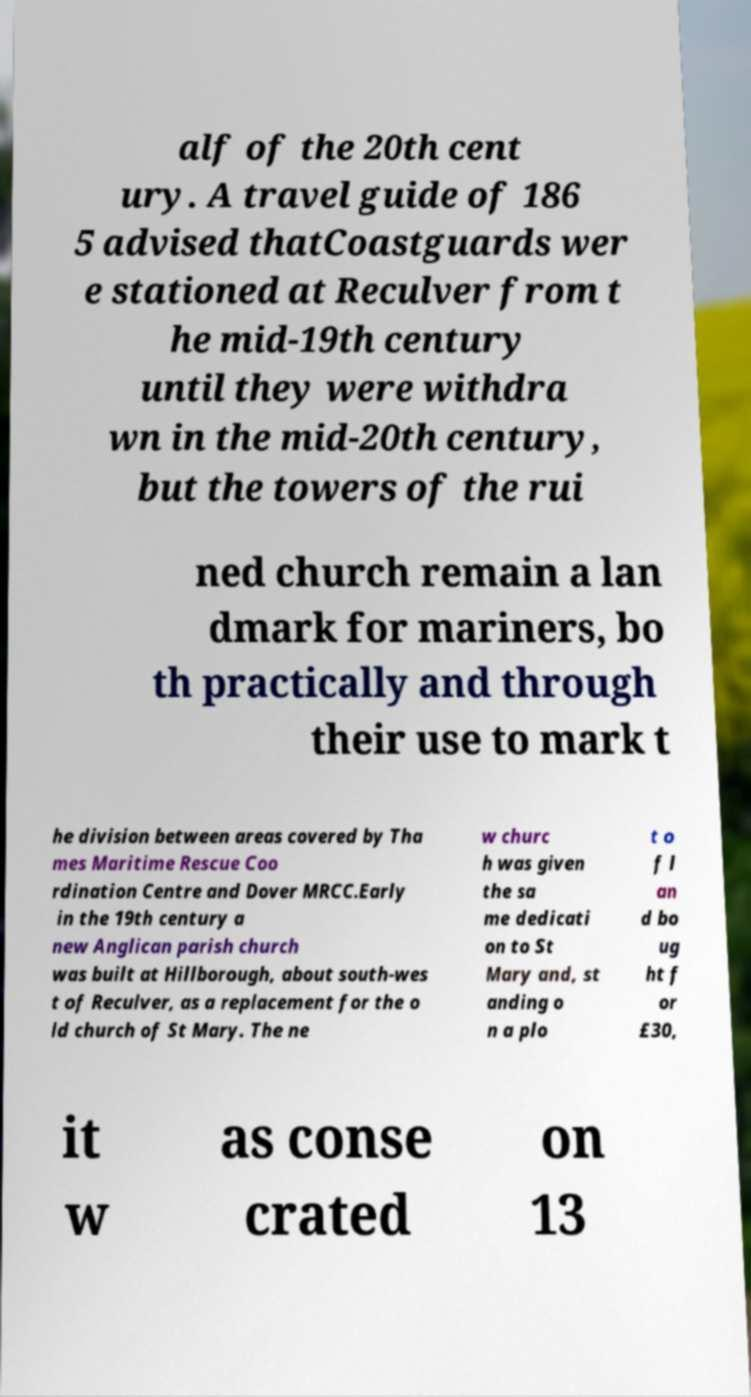Could you assist in decoding the text presented in this image and type it out clearly? alf of the 20th cent ury. A travel guide of 186 5 advised thatCoastguards wer e stationed at Reculver from t he mid-19th century until they were withdra wn in the mid-20th century, but the towers of the rui ned church remain a lan dmark for mariners, bo th practically and through their use to mark t he division between areas covered by Tha mes Maritime Rescue Coo rdination Centre and Dover MRCC.Early in the 19th century a new Anglican parish church was built at Hillborough, about south-wes t of Reculver, as a replacement for the o ld church of St Mary. The ne w churc h was given the sa me dedicati on to St Mary and, st anding o n a plo t o f l an d bo ug ht f or £30, it w as conse crated on 13 